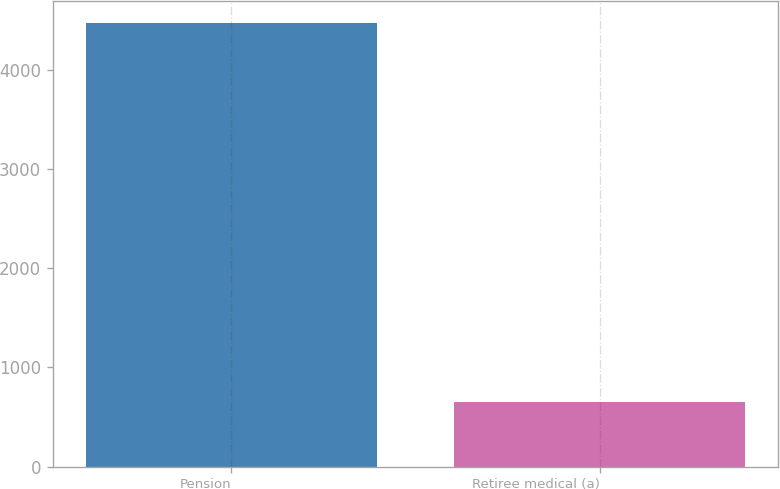Convert chart. <chart><loc_0><loc_0><loc_500><loc_500><bar_chart><fcel>Pension<fcel>Retiree medical (a)<nl><fcel>4465<fcel>655<nl></chart> 